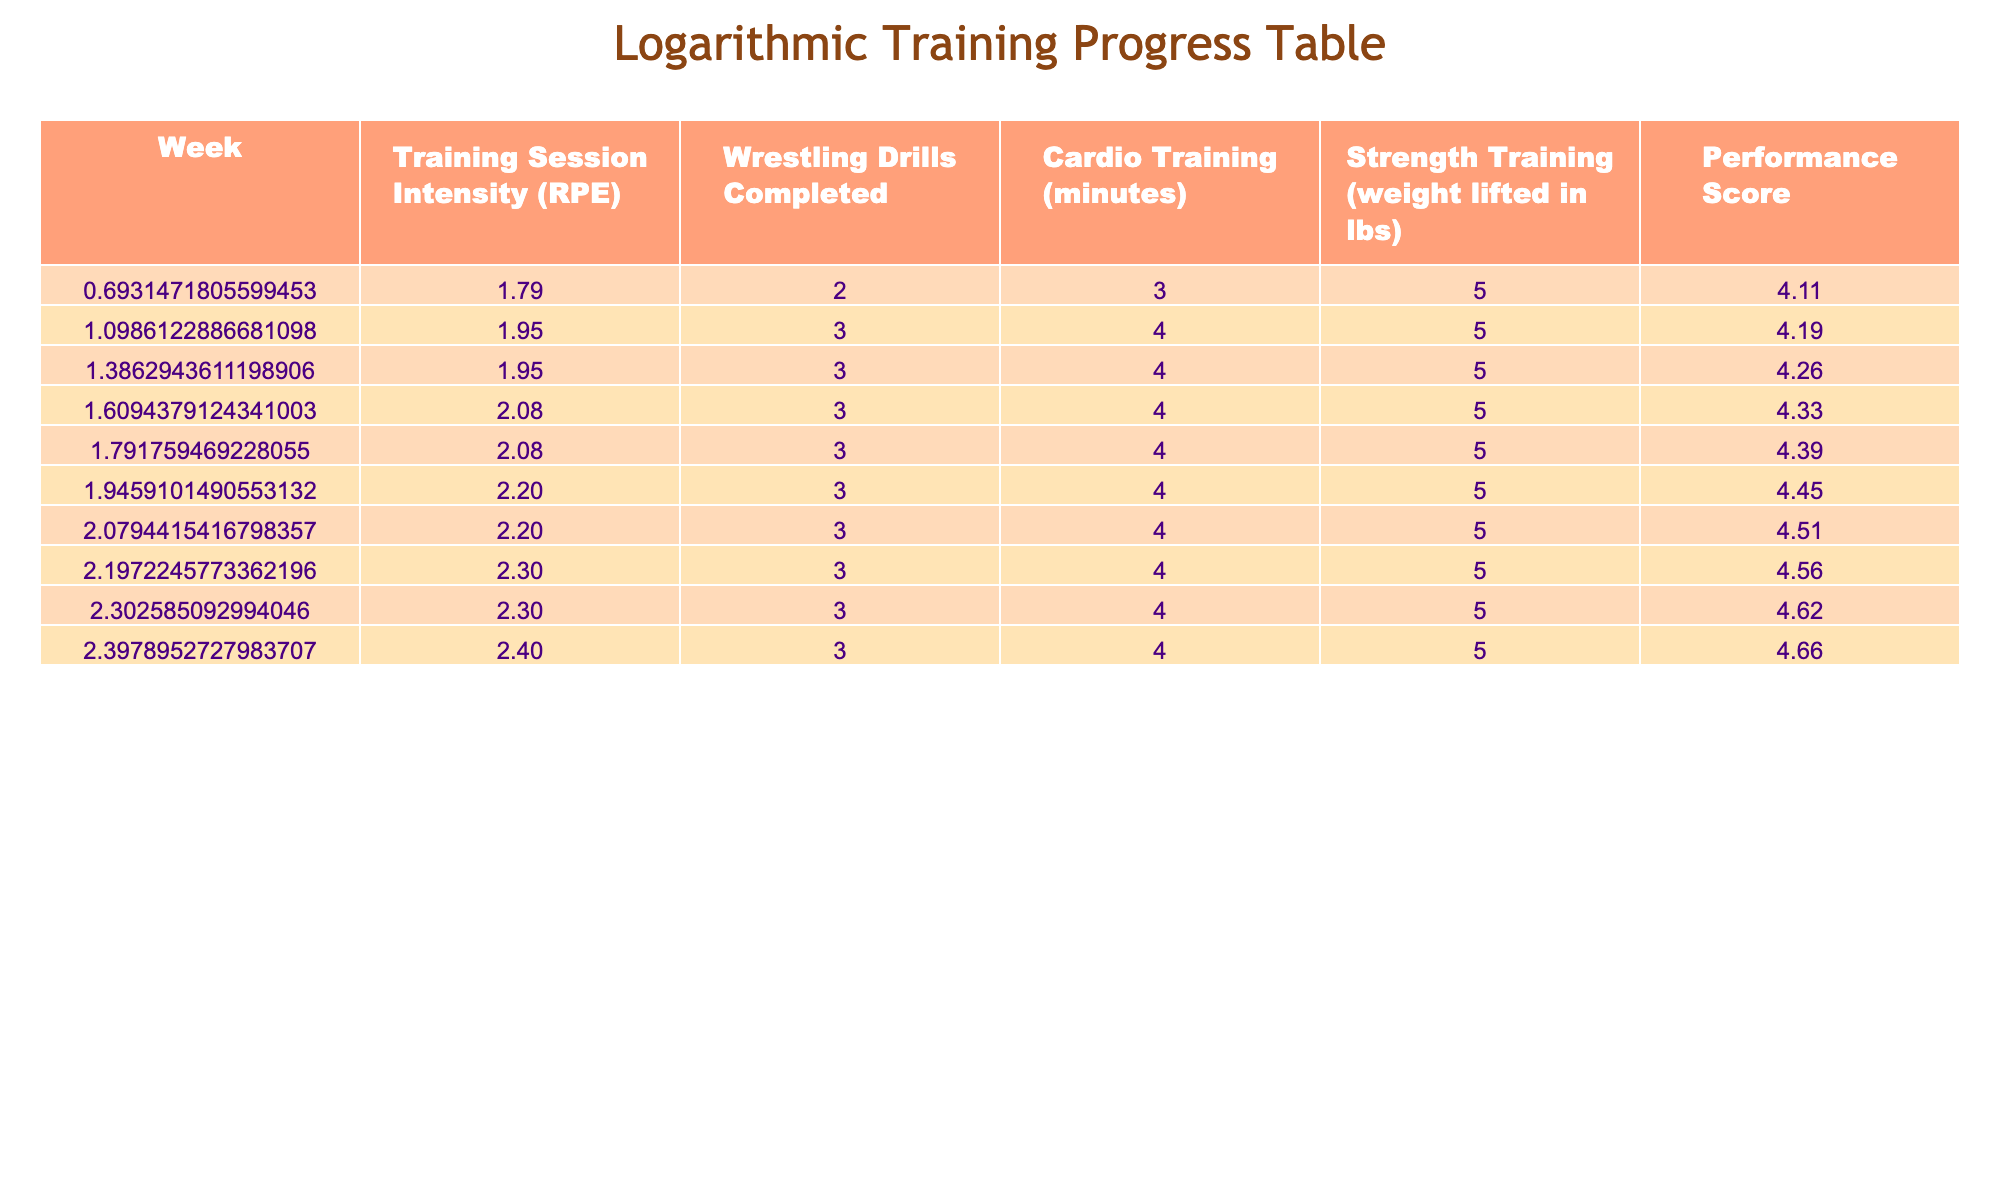What was the Training Session Intensity in week 6? According to the table, the Training Session Intensity for week 6 is listed directly. It shows a value of 8.
Answer: 8 What is the total number of Wrestling Drills Completed from week 1 to week 10? To find the total number of Wrestling Drills Completed, sum the values from each week: 10 + 12 + 13 + 15 + 16 + 18 + 19 + 22 + 23 + 25 =  10 + 12 + 13 + 15 + 16 + 18 + 19 + 22 + 23 + 25 =  100
Answer: 100 In which week was the Performance Score 90? By analyzing the Performance Score column, we can see that week 7 has a Performance Score of 90.
Answer: 7 Did the Cardio Training increase every week? By reviewing the Cardio Training column, we find that each subsequent week values are greater than the previous ones: 30, 35, 40, 45, 50, 55, 60, 65, 70, 75. Therefore, it did indeed increase every week.
Answer: Yes What is the average weight lifted in strength training over the 10 weeks? To calculate the average weight lifted, sum the numbers in the Strength Training column: 150 + 160 + 170 + 180 + 190 + 200 + 210 + 220 + 230 + 240 =  2,000. Dividing by the number of weeks (10): 2000 / 10 = 200.
Answer: 200 In which week did the Training Session Intensity first reach 9? The Training Session Intensity first reaches 9 in week 8, according to the table.
Answer: 8 What is the difference between the Performance Score in week 10 and week 1? To find the difference, subtract the Performance Score in week 1 from that in week 10: 105 (week 10) - 60 (week 1) = 45.
Answer: 45 Is it true that the number of Wrestling Drills Completed doubled from week 1 to week 10? To verify if it doubled, check the values: week 1 had 10 drills and week 10 has 25 drills. Since 25 is not double 10, the statement is false.
Answer: No What can be stated about the trend of Training Session Intensity over the weeks? From the values in the Training Session Intensity column, it demonstrates a clear upward trend, starting at 5 in week 1 and reaching 10 in week 10, indicating consistent improvement in training intensity.
Answer: Increasing 